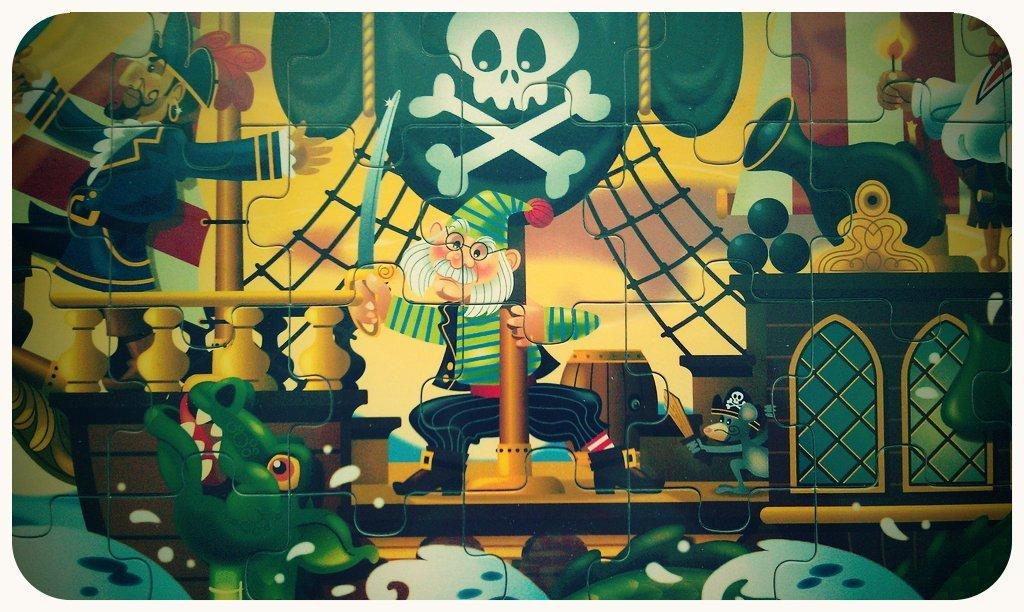What type of game is shown in the picture? There is a puzzle game in the picture. What are the components of the puzzle game? The puzzle has cards. What can be seen on the cards? The cards have pictures of cartoon characters and other objects. What type of bird can be seen sitting on the furniture in the image? There is no bird or furniture present in the image; it features a puzzle game with cards. 